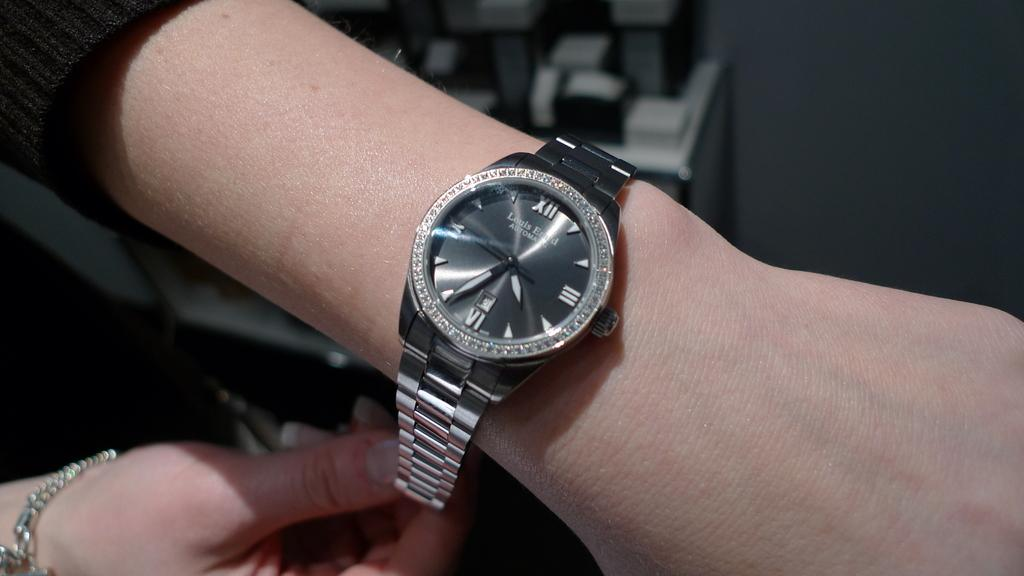<image>
Offer a succinct explanation of the picture presented. A Louis Erard watch with diamonds around the edge of it. 